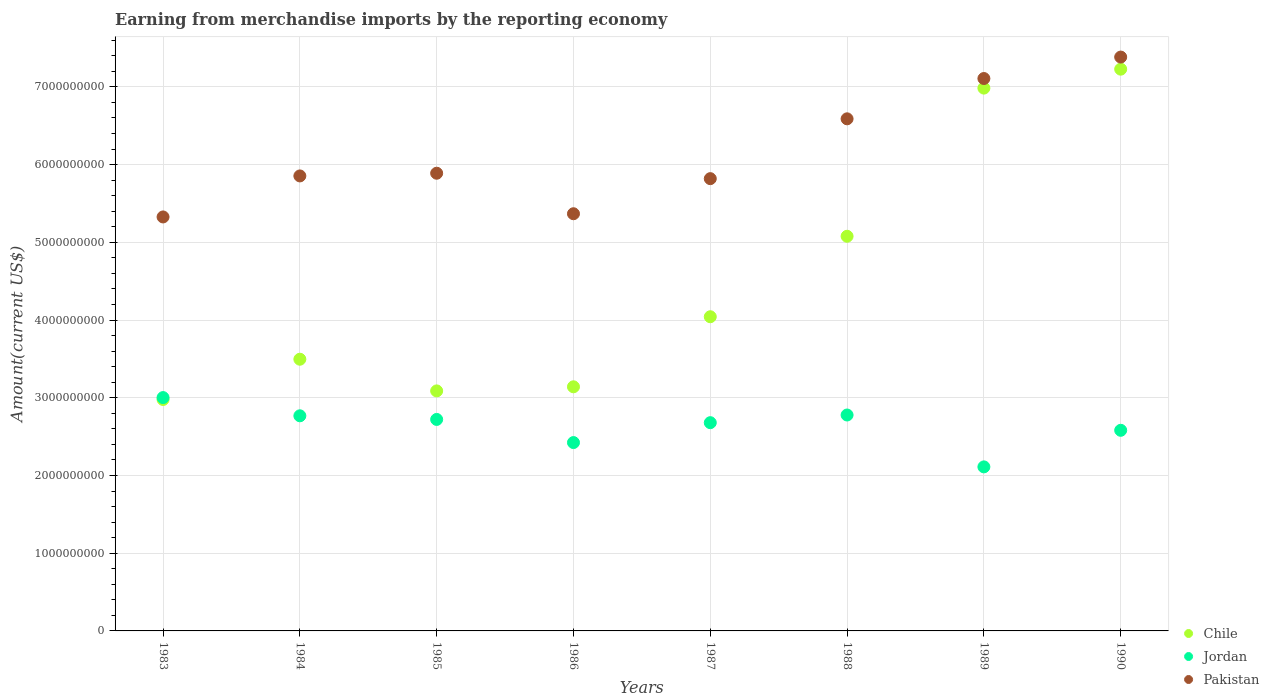What is the amount earned from merchandise imports in Chile in 1985?
Provide a succinct answer. 3.09e+09. Across all years, what is the maximum amount earned from merchandise imports in Pakistan?
Give a very brief answer. 7.38e+09. Across all years, what is the minimum amount earned from merchandise imports in Pakistan?
Your response must be concise. 5.33e+09. In which year was the amount earned from merchandise imports in Pakistan maximum?
Your answer should be very brief. 1990. In which year was the amount earned from merchandise imports in Chile minimum?
Provide a succinct answer. 1983. What is the total amount earned from merchandise imports in Chile in the graph?
Make the answer very short. 3.60e+1. What is the difference between the amount earned from merchandise imports in Chile in 1986 and that in 1988?
Offer a very short reply. -1.94e+09. What is the difference between the amount earned from merchandise imports in Jordan in 1985 and the amount earned from merchandise imports in Pakistan in 1988?
Your response must be concise. -3.87e+09. What is the average amount earned from merchandise imports in Jordan per year?
Your answer should be very brief. 2.63e+09. In the year 1987, what is the difference between the amount earned from merchandise imports in Pakistan and amount earned from merchandise imports in Jordan?
Give a very brief answer. 3.14e+09. In how many years, is the amount earned from merchandise imports in Pakistan greater than 3400000000 US$?
Provide a short and direct response. 8. What is the ratio of the amount earned from merchandise imports in Jordan in 1983 to that in 1985?
Keep it short and to the point. 1.1. Is the amount earned from merchandise imports in Pakistan in 1985 less than that in 1988?
Provide a succinct answer. Yes. Is the difference between the amount earned from merchandise imports in Pakistan in 1983 and 1986 greater than the difference between the amount earned from merchandise imports in Jordan in 1983 and 1986?
Offer a terse response. No. What is the difference between the highest and the second highest amount earned from merchandise imports in Chile?
Ensure brevity in your answer.  2.44e+08. What is the difference between the highest and the lowest amount earned from merchandise imports in Chile?
Your answer should be very brief. 4.25e+09. In how many years, is the amount earned from merchandise imports in Pakistan greater than the average amount earned from merchandise imports in Pakistan taken over all years?
Your answer should be very brief. 3. Is the sum of the amount earned from merchandise imports in Jordan in 1983 and 1984 greater than the maximum amount earned from merchandise imports in Chile across all years?
Ensure brevity in your answer.  No. Does the amount earned from merchandise imports in Jordan monotonically increase over the years?
Provide a short and direct response. No. Is the amount earned from merchandise imports in Chile strictly less than the amount earned from merchandise imports in Jordan over the years?
Give a very brief answer. No. How many dotlines are there?
Keep it short and to the point. 3. Are the values on the major ticks of Y-axis written in scientific E-notation?
Provide a succinct answer. No. How are the legend labels stacked?
Your answer should be compact. Vertical. What is the title of the graph?
Your response must be concise. Earning from merchandise imports by the reporting economy. Does "Central African Republic" appear as one of the legend labels in the graph?
Ensure brevity in your answer.  No. What is the label or title of the X-axis?
Keep it short and to the point. Years. What is the label or title of the Y-axis?
Your response must be concise. Amount(current US$). What is the Amount(current US$) of Chile in 1983?
Make the answer very short. 2.98e+09. What is the Amount(current US$) in Jordan in 1983?
Offer a very short reply. 3.00e+09. What is the Amount(current US$) of Pakistan in 1983?
Offer a very short reply. 5.33e+09. What is the Amount(current US$) of Chile in 1984?
Offer a very short reply. 3.50e+09. What is the Amount(current US$) of Jordan in 1984?
Offer a terse response. 2.77e+09. What is the Amount(current US$) of Pakistan in 1984?
Ensure brevity in your answer.  5.85e+09. What is the Amount(current US$) of Chile in 1985?
Give a very brief answer. 3.09e+09. What is the Amount(current US$) in Jordan in 1985?
Offer a very short reply. 2.72e+09. What is the Amount(current US$) in Pakistan in 1985?
Ensure brevity in your answer.  5.89e+09. What is the Amount(current US$) of Chile in 1986?
Keep it short and to the point. 3.14e+09. What is the Amount(current US$) in Jordan in 1986?
Your answer should be compact. 2.42e+09. What is the Amount(current US$) of Pakistan in 1986?
Your answer should be compact. 5.37e+09. What is the Amount(current US$) of Chile in 1987?
Your answer should be very brief. 4.04e+09. What is the Amount(current US$) of Jordan in 1987?
Your answer should be very brief. 2.68e+09. What is the Amount(current US$) of Pakistan in 1987?
Give a very brief answer. 5.82e+09. What is the Amount(current US$) in Chile in 1988?
Give a very brief answer. 5.08e+09. What is the Amount(current US$) of Jordan in 1988?
Give a very brief answer. 2.78e+09. What is the Amount(current US$) of Pakistan in 1988?
Offer a terse response. 6.59e+09. What is the Amount(current US$) in Chile in 1989?
Give a very brief answer. 6.98e+09. What is the Amount(current US$) in Jordan in 1989?
Offer a terse response. 2.11e+09. What is the Amount(current US$) of Pakistan in 1989?
Provide a short and direct response. 7.11e+09. What is the Amount(current US$) of Chile in 1990?
Make the answer very short. 7.23e+09. What is the Amount(current US$) of Jordan in 1990?
Your answer should be compact. 2.58e+09. What is the Amount(current US$) of Pakistan in 1990?
Offer a very short reply. 7.38e+09. Across all years, what is the maximum Amount(current US$) of Chile?
Your response must be concise. 7.23e+09. Across all years, what is the maximum Amount(current US$) in Jordan?
Offer a terse response. 3.00e+09. Across all years, what is the maximum Amount(current US$) in Pakistan?
Give a very brief answer. 7.38e+09. Across all years, what is the minimum Amount(current US$) in Chile?
Make the answer very short. 2.98e+09. Across all years, what is the minimum Amount(current US$) in Jordan?
Your response must be concise. 2.11e+09. Across all years, what is the minimum Amount(current US$) of Pakistan?
Give a very brief answer. 5.33e+09. What is the total Amount(current US$) of Chile in the graph?
Keep it short and to the point. 3.60e+1. What is the total Amount(current US$) of Jordan in the graph?
Offer a terse response. 2.11e+1. What is the total Amount(current US$) of Pakistan in the graph?
Provide a short and direct response. 4.93e+1. What is the difference between the Amount(current US$) of Chile in 1983 and that in 1984?
Keep it short and to the point. -5.18e+08. What is the difference between the Amount(current US$) of Jordan in 1983 and that in 1984?
Keep it short and to the point. 2.34e+08. What is the difference between the Amount(current US$) in Pakistan in 1983 and that in 1984?
Offer a terse response. -5.28e+08. What is the difference between the Amount(current US$) in Chile in 1983 and that in 1985?
Give a very brief answer. -1.10e+08. What is the difference between the Amount(current US$) of Jordan in 1983 and that in 1985?
Your response must be concise. 2.81e+08. What is the difference between the Amount(current US$) of Pakistan in 1983 and that in 1985?
Your response must be concise. -5.62e+08. What is the difference between the Amount(current US$) in Chile in 1983 and that in 1986?
Your answer should be compact. -1.63e+08. What is the difference between the Amount(current US$) of Jordan in 1983 and that in 1986?
Your answer should be very brief. 5.79e+08. What is the difference between the Amount(current US$) of Pakistan in 1983 and that in 1986?
Your answer should be compact. -4.12e+07. What is the difference between the Amount(current US$) of Chile in 1983 and that in 1987?
Offer a terse response. -1.06e+09. What is the difference between the Amount(current US$) in Jordan in 1983 and that in 1987?
Offer a terse response. 3.23e+08. What is the difference between the Amount(current US$) of Pakistan in 1983 and that in 1987?
Your response must be concise. -4.93e+08. What is the difference between the Amount(current US$) of Chile in 1983 and that in 1988?
Provide a short and direct response. -2.10e+09. What is the difference between the Amount(current US$) in Jordan in 1983 and that in 1988?
Make the answer very short. 2.24e+08. What is the difference between the Amount(current US$) of Pakistan in 1983 and that in 1988?
Provide a succinct answer. -1.26e+09. What is the difference between the Amount(current US$) of Chile in 1983 and that in 1989?
Offer a very short reply. -4.01e+09. What is the difference between the Amount(current US$) of Jordan in 1983 and that in 1989?
Provide a short and direct response. 8.91e+08. What is the difference between the Amount(current US$) of Pakistan in 1983 and that in 1989?
Provide a short and direct response. -1.78e+09. What is the difference between the Amount(current US$) in Chile in 1983 and that in 1990?
Provide a short and direct response. -4.25e+09. What is the difference between the Amount(current US$) in Jordan in 1983 and that in 1990?
Provide a short and direct response. 4.21e+08. What is the difference between the Amount(current US$) of Pakistan in 1983 and that in 1990?
Keep it short and to the point. -2.06e+09. What is the difference between the Amount(current US$) of Chile in 1984 and that in 1985?
Give a very brief answer. 4.08e+08. What is the difference between the Amount(current US$) of Jordan in 1984 and that in 1985?
Provide a succinct answer. 4.66e+07. What is the difference between the Amount(current US$) of Pakistan in 1984 and that in 1985?
Ensure brevity in your answer.  -3.47e+07. What is the difference between the Amount(current US$) of Chile in 1984 and that in 1986?
Offer a terse response. 3.55e+08. What is the difference between the Amount(current US$) in Jordan in 1984 and that in 1986?
Provide a succinct answer. 3.44e+08. What is the difference between the Amount(current US$) of Pakistan in 1984 and that in 1986?
Offer a terse response. 4.87e+08. What is the difference between the Amount(current US$) of Chile in 1984 and that in 1987?
Offer a terse response. -5.47e+08. What is the difference between the Amount(current US$) of Jordan in 1984 and that in 1987?
Your answer should be very brief. 8.84e+07. What is the difference between the Amount(current US$) in Pakistan in 1984 and that in 1987?
Your answer should be very brief. 3.51e+07. What is the difference between the Amount(current US$) of Chile in 1984 and that in 1988?
Your response must be concise. -1.58e+09. What is the difference between the Amount(current US$) in Jordan in 1984 and that in 1988?
Provide a short and direct response. -1.03e+07. What is the difference between the Amount(current US$) in Pakistan in 1984 and that in 1988?
Provide a succinct answer. -7.35e+08. What is the difference between the Amount(current US$) in Chile in 1984 and that in 1989?
Your answer should be compact. -3.49e+09. What is the difference between the Amount(current US$) in Jordan in 1984 and that in 1989?
Give a very brief answer. 6.57e+08. What is the difference between the Amount(current US$) in Pakistan in 1984 and that in 1989?
Your answer should be compact. -1.25e+09. What is the difference between the Amount(current US$) of Chile in 1984 and that in 1990?
Your answer should be very brief. -3.73e+09. What is the difference between the Amount(current US$) of Jordan in 1984 and that in 1990?
Keep it short and to the point. 1.87e+08. What is the difference between the Amount(current US$) in Pakistan in 1984 and that in 1990?
Provide a succinct answer. -1.53e+09. What is the difference between the Amount(current US$) of Chile in 1985 and that in 1986?
Ensure brevity in your answer.  -5.28e+07. What is the difference between the Amount(current US$) in Jordan in 1985 and that in 1986?
Offer a terse response. 2.98e+08. What is the difference between the Amount(current US$) of Pakistan in 1985 and that in 1986?
Make the answer very short. 5.21e+08. What is the difference between the Amount(current US$) of Chile in 1985 and that in 1987?
Your answer should be compact. -9.54e+08. What is the difference between the Amount(current US$) of Jordan in 1985 and that in 1987?
Make the answer very short. 4.18e+07. What is the difference between the Amount(current US$) of Pakistan in 1985 and that in 1987?
Offer a terse response. 6.98e+07. What is the difference between the Amount(current US$) of Chile in 1985 and that in 1988?
Offer a terse response. -1.99e+09. What is the difference between the Amount(current US$) of Jordan in 1985 and that in 1988?
Ensure brevity in your answer.  -5.70e+07. What is the difference between the Amount(current US$) in Pakistan in 1985 and that in 1988?
Your answer should be very brief. -7.00e+08. What is the difference between the Amount(current US$) in Chile in 1985 and that in 1989?
Ensure brevity in your answer.  -3.90e+09. What is the difference between the Amount(current US$) in Jordan in 1985 and that in 1989?
Your answer should be very brief. 6.10e+08. What is the difference between the Amount(current US$) in Pakistan in 1985 and that in 1989?
Provide a short and direct response. -1.22e+09. What is the difference between the Amount(current US$) of Chile in 1985 and that in 1990?
Make the answer very short. -4.14e+09. What is the difference between the Amount(current US$) of Jordan in 1985 and that in 1990?
Your response must be concise. 1.40e+08. What is the difference between the Amount(current US$) in Pakistan in 1985 and that in 1990?
Offer a very short reply. -1.49e+09. What is the difference between the Amount(current US$) of Chile in 1986 and that in 1987?
Your answer should be very brief. -9.01e+08. What is the difference between the Amount(current US$) of Jordan in 1986 and that in 1987?
Your answer should be compact. -2.56e+08. What is the difference between the Amount(current US$) of Pakistan in 1986 and that in 1987?
Provide a short and direct response. -4.52e+08. What is the difference between the Amount(current US$) in Chile in 1986 and that in 1988?
Give a very brief answer. -1.94e+09. What is the difference between the Amount(current US$) in Jordan in 1986 and that in 1988?
Your response must be concise. -3.55e+08. What is the difference between the Amount(current US$) of Pakistan in 1986 and that in 1988?
Your answer should be compact. -1.22e+09. What is the difference between the Amount(current US$) of Chile in 1986 and that in 1989?
Keep it short and to the point. -3.84e+09. What is the difference between the Amount(current US$) of Jordan in 1986 and that in 1989?
Keep it short and to the point. 3.13e+08. What is the difference between the Amount(current US$) of Pakistan in 1986 and that in 1989?
Your answer should be very brief. -1.74e+09. What is the difference between the Amount(current US$) of Chile in 1986 and that in 1990?
Offer a very short reply. -4.09e+09. What is the difference between the Amount(current US$) of Jordan in 1986 and that in 1990?
Offer a terse response. -1.58e+08. What is the difference between the Amount(current US$) in Pakistan in 1986 and that in 1990?
Offer a very short reply. -2.02e+09. What is the difference between the Amount(current US$) of Chile in 1987 and that in 1988?
Provide a short and direct response. -1.04e+09. What is the difference between the Amount(current US$) in Jordan in 1987 and that in 1988?
Give a very brief answer. -9.88e+07. What is the difference between the Amount(current US$) of Pakistan in 1987 and that in 1988?
Your answer should be compact. -7.70e+08. What is the difference between the Amount(current US$) in Chile in 1987 and that in 1989?
Provide a short and direct response. -2.94e+09. What is the difference between the Amount(current US$) of Jordan in 1987 and that in 1989?
Keep it short and to the point. 5.69e+08. What is the difference between the Amount(current US$) of Pakistan in 1987 and that in 1989?
Your response must be concise. -1.29e+09. What is the difference between the Amount(current US$) of Chile in 1987 and that in 1990?
Your answer should be very brief. -3.19e+09. What is the difference between the Amount(current US$) in Jordan in 1987 and that in 1990?
Offer a terse response. 9.81e+07. What is the difference between the Amount(current US$) of Pakistan in 1987 and that in 1990?
Provide a short and direct response. -1.56e+09. What is the difference between the Amount(current US$) of Chile in 1988 and that in 1989?
Make the answer very short. -1.91e+09. What is the difference between the Amount(current US$) in Jordan in 1988 and that in 1989?
Offer a very short reply. 6.67e+08. What is the difference between the Amount(current US$) of Pakistan in 1988 and that in 1989?
Give a very brief answer. -5.19e+08. What is the difference between the Amount(current US$) of Chile in 1988 and that in 1990?
Give a very brief answer. -2.15e+09. What is the difference between the Amount(current US$) of Jordan in 1988 and that in 1990?
Your answer should be very brief. 1.97e+08. What is the difference between the Amount(current US$) in Pakistan in 1988 and that in 1990?
Your answer should be compact. -7.95e+08. What is the difference between the Amount(current US$) of Chile in 1989 and that in 1990?
Your response must be concise. -2.44e+08. What is the difference between the Amount(current US$) of Jordan in 1989 and that in 1990?
Keep it short and to the point. -4.71e+08. What is the difference between the Amount(current US$) in Pakistan in 1989 and that in 1990?
Your answer should be very brief. -2.76e+08. What is the difference between the Amount(current US$) in Chile in 1983 and the Amount(current US$) in Jordan in 1984?
Your answer should be compact. 2.10e+08. What is the difference between the Amount(current US$) in Chile in 1983 and the Amount(current US$) in Pakistan in 1984?
Your answer should be compact. -2.88e+09. What is the difference between the Amount(current US$) of Jordan in 1983 and the Amount(current US$) of Pakistan in 1984?
Make the answer very short. -2.85e+09. What is the difference between the Amount(current US$) in Chile in 1983 and the Amount(current US$) in Jordan in 1985?
Provide a succinct answer. 2.57e+08. What is the difference between the Amount(current US$) in Chile in 1983 and the Amount(current US$) in Pakistan in 1985?
Your answer should be compact. -2.91e+09. What is the difference between the Amount(current US$) in Jordan in 1983 and the Amount(current US$) in Pakistan in 1985?
Provide a short and direct response. -2.89e+09. What is the difference between the Amount(current US$) in Chile in 1983 and the Amount(current US$) in Jordan in 1986?
Keep it short and to the point. 5.54e+08. What is the difference between the Amount(current US$) in Chile in 1983 and the Amount(current US$) in Pakistan in 1986?
Your answer should be compact. -2.39e+09. What is the difference between the Amount(current US$) of Jordan in 1983 and the Amount(current US$) of Pakistan in 1986?
Provide a succinct answer. -2.37e+09. What is the difference between the Amount(current US$) of Chile in 1983 and the Amount(current US$) of Jordan in 1987?
Provide a succinct answer. 2.98e+08. What is the difference between the Amount(current US$) of Chile in 1983 and the Amount(current US$) of Pakistan in 1987?
Provide a short and direct response. -2.84e+09. What is the difference between the Amount(current US$) of Jordan in 1983 and the Amount(current US$) of Pakistan in 1987?
Offer a very short reply. -2.82e+09. What is the difference between the Amount(current US$) of Chile in 1983 and the Amount(current US$) of Jordan in 1988?
Make the answer very short. 2.00e+08. What is the difference between the Amount(current US$) in Chile in 1983 and the Amount(current US$) in Pakistan in 1988?
Your answer should be compact. -3.61e+09. What is the difference between the Amount(current US$) in Jordan in 1983 and the Amount(current US$) in Pakistan in 1988?
Your answer should be very brief. -3.59e+09. What is the difference between the Amount(current US$) of Chile in 1983 and the Amount(current US$) of Jordan in 1989?
Your response must be concise. 8.67e+08. What is the difference between the Amount(current US$) in Chile in 1983 and the Amount(current US$) in Pakistan in 1989?
Ensure brevity in your answer.  -4.13e+09. What is the difference between the Amount(current US$) of Jordan in 1983 and the Amount(current US$) of Pakistan in 1989?
Provide a short and direct response. -4.11e+09. What is the difference between the Amount(current US$) in Chile in 1983 and the Amount(current US$) in Jordan in 1990?
Give a very brief answer. 3.97e+08. What is the difference between the Amount(current US$) in Chile in 1983 and the Amount(current US$) in Pakistan in 1990?
Provide a short and direct response. -4.41e+09. What is the difference between the Amount(current US$) of Jordan in 1983 and the Amount(current US$) of Pakistan in 1990?
Your response must be concise. -4.38e+09. What is the difference between the Amount(current US$) of Chile in 1984 and the Amount(current US$) of Jordan in 1985?
Make the answer very short. 7.75e+08. What is the difference between the Amount(current US$) of Chile in 1984 and the Amount(current US$) of Pakistan in 1985?
Provide a succinct answer. -2.39e+09. What is the difference between the Amount(current US$) in Jordan in 1984 and the Amount(current US$) in Pakistan in 1985?
Ensure brevity in your answer.  -3.12e+09. What is the difference between the Amount(current US$) of Chile in 1984 and the Amount(current US$) of Jordan in 1986?
Provide a short and direct response. 1.07e+09. What is the difference between the Amount(current US$) in Chile in 1984 and the Amount(current US$) in Pakistan in 1986?
Provide a short and direct response. -1.87e+09. What is the difference between the Amount(current US$) in Jordan in 1984 and the Amount(current US$) in Pakistan in 1986?
Your response must be concise. -2.60e+09. What is the difference between the Amount(current US$) in Chile in 1984 and the Amount(current US$) in Jordan in 1987?
Give a very brief answer. 8.16e+08. What is the difference between the Amount(current US$) of Chile in 1984 and the Amount(current US$) of Pakistan in 1987?
Your answer should be very brief. -2.32e+09. What is the difference between the Amount(current US$) in Jordan in 1984 and the Amount(current US$) in Pakistan in 1987?
Keep it short and to the point. -3.05e+09. What is the difference between the Amount(current US$) of Chile in 1984 and the Amount(current US$) of Jordan in 1988?
Offer a very short reply. 7.18e+08. What is the difference between the Amount(current US$) in Chile in 1984 and the Amount(current US$) in Pakistan in 1988?
Give a very brief answer. -3.09e+09. What is the difference between the Amount(current US$) of Jordan in 1984 and the Amount(current US$) of Pakistan in 1988?
Provide a short and direct response. -3.82e+09. What is the difference between the Amount(current US$) in Chile in 1984 and the Amount(current US$) in Jordan in 1989?
Ensure brevity in your answer.  1.38e+09. What is the difference between the Amount(current US$) of Chile in 1984 and the Amount(current US$) of Pakistan in 1989?
Provide a short and direct response. -3.61e+09. What is the difference between the Amount(current US$) of Jordan in 1984 and the Amount(current US$) of Pakistan in 1989?
Keep it short and to the point. -4.34e+09. What is the difference between the Amount(current US$) in Chile in 1984 and the Amount(current US$) in Jordan in 1990?
Your answer should be compact. 9.14e+08. What is the difference between the Amount(current US$) in Chile in 1984 and the Amount(current US$) in Pakistan in 1990?
Offer a terse response. -3.89e+09. What is the difference between the Amount(current US$) of Jordan in 1984 and the Amount(current US$) of Pakistan in 1990?
Your answer should be very brief. -4.62e+09. What is the difference between the Amount(current US$) of Chile in 1985 and the Amount(current US$) of Jordan in 1986?
Make the answer very short. 6.65e+08. What is the difference between the Amount(current US$) in Chile in 1985 and the Amount(current US$) in Pakistan in 1986?
Make the answer very short. -2.28e+09. What is the difference between the Amount(current US$) in Jordan in 1985 and the Amount(current US$) in Pakistan in 1986?
Provide a succinct answer. -2.65e+09. What is the difference between the Amount(current US$) in Chile in 1985 and the Amount(current US$) in Jordan in 1987?
Keep it short and to the point. 4.09e+08. What is the difference between the Amount(current US$) of Chile in 1985 and the Amount(current US$) of Pakistan in 1987?
Your response must be concise. -2.73e+09. What is the difference between the Amount(current US$) in Jordan in 1985 and the Amount(current US$) in Pakistan in 1987?
Your response must be concise. -3.10e+09. What is the difference between the Amount(current US$) of Chile in 1985 and the Amount(current US$) of Jordan in 1988?
Provide a short and direct response. 3.10e+08. What is the difference between the Amount(current US$) in Chile in 1985 and the Amount(current US$) in Pakistan in 1988?
Give a very brief answer. -3.50e+09. What is the difference between the Amount(current US$) of Jordan in 1985 and the Amount(current US$) of Pakistan in 1988?
Offer a terse response. -3.87e+09. What is the difference between the Amount(current US$) in Chile in 1985 and the Amount(current US$) in Jordan in 1989?
Your answer should be very brief. 9.77e+08. What is the difference between the Amount(current US$) in Chile in 1985 and the Amount(current US$) in Pakistan in 1989?
Provide a short and direct response. -4.02e+09. What is the difference between the Amount(current US$) of Jordan in 1985 and the Amount(current US$) of Pakistan in 1989?
Ensure brevity in your answer.  -4.39e+09. What is the difference between the Amount(current US$) in Chile in 1985 and the Amount(current US$) in Jordan in 1990?
Ensure brevity in your answer.  5.07e+08. What is the difference between the Amount(current US$) of Chile in 1985 and the Amount(current US$) of Pakistan in 1990?
Keep it short and to the point. -4.30e+09. What is the difference between the Amount(current US$) in Jordan in 1985 and the Amount(current US$) in Pakistan in 1990?
Make the answer very short. -4.66e+09. What is the difference between the Amount(current US$) of Chile in 1986 and the Amount(current US$) of Jordan in 1987?
Make the answer very short. 4.62e+08. What is the difference between the Amount(current US$) of Chile in 1986 and the Amount(current US$) of Pakistan in 1987?
Make the answer very short. -2.68e+09. What is the difference between the Amount(current US$) of Jordan in 1986 and the Amount(current US$) of Pakistan in 1987?
Give a very brief answer. -3.40e+09. What is the difference between the Amount(current US$) in Chile in 1986 and the Amount(current US$) in Jordan in 1988?
Offer a terse response. 3.63e+08. What is the difference between the Amount(current US$) of Chile in 1986 and the Amount(current US$) of Pakistan in 1988?
Offer a terse response. -3.45e+09. What is the difference between the Amount(current US$) of Jordan in 1986 and the Amount(current US$) of Pakistan in 1988?
Keep it short and to the point. -4.17e+09. What is the difference between the Amount(current US$) of Chile in 1986 and the Amount(current US$) of Jordan in 1989?
Keep it short and to the point. 1.03e+09. What is the difference between the Amount(current US$) in Chile in 1986 and the Amount(current US$) in Pakistan in 1989?
Keep it short and to the point. -3.97e+09. What is the difference between the Amount(current US$) in Jordan in 1986 and the Amount(current US$) in Pakistan in 1989?
Provide a succinct answer. -4.68e+09. What is the difference between the Amount(current US$) in Chile in 1986 and the Amount(current US$) in Jordan in 1990?
Your answer should be compact. 5.60e+08. What is the difference between the Amount(current US$) in Chile in 1986 and the Amount(current US$) in Pakistan in 1990?
Make the answer very short. -4.24e+09. What is the difference between the Amount(current US$) in Jordan in 1986 and the Amount(current US$) in Pakistan in 1990?
Provide a short and direct response. -4.96e+09. What is the difference between the Amount(current US$) in Chile in 1987 and the Amount(current US$) in Jordan in 1988?
Give a very brief answer. 1.26e+09. What is the difference between the Amount(current US$) of Chile in 1987 and the Amount(current US$) of Pakistan in 1988?
Offer a very short reply. -2.55e+09. What is the difference between the Amount(current US$) of Jordan in 1987 and the Amount(current US$) of Pakistan in 1988?
Offer a very short reply. -3.91e+09. What is the difference between the Amount(current US$) of Chile in 1987 and the Amount(current US$) of Jordan in 1989?
Offer a terse response. 1.93e+09. What is the difference between the Amount(current US$) in Chile in 1987 and the Amount(current US$) in Pakistan in 1989?
Give a very brief answer. -3.06e+09. What is the difference between the Amount(current US$) in Jordan in 1987 and the Amount(current US$) in Pakistan in 1989?
Give a very brief answer. -4.43e+09. What is the difference between the Amount(current US$) of Chile in 1987 and the Amount(current US$) of Jordan in 1990?
Ensure brevity in your answer.  1.46e+09. What is the difference between the Amount(current US$) of Chile in 1987 and the Amount(current US$) of Pakistan in 1990?
Offer a very short reply. -3.34e+09. What is the difference between the Amount(current US$) of Jordan in 1987 and the Amount(current US$) of Pakistan in 1990?
Your response must be concise. -4.70e+09. What is the difference between the Amount(current US$) of Chile in 1988 and the Amount(current US$) of Jordan in 1989?
Provide a succinct answer. 2.97e+09. What is the difference between the Amount(current US$) in Chile in 1988 and the Amount(current US$) in Pakistan in 1989?
Make the answer very short. -2.03e+09. What is the difference between the Amount(current US$) of Jordan in 1988 and the Amount(current US$) of Pakistan in 1989?
Provide a short and direct response. -4.33e+09. What is the difference between the Amount(current US$) in Chile in 1988 and the Amount(current US$) in Jordan in 1990?
Your response must be concise. 2.50e+09. What is the difference between the Amount(current US$) of Chile in 1988 and the Amount(current US$) of Pakistan in 1990?
Keep it short and to the point. -2.31e+09. What is the difference between the Amount(current US$) in Jordan in 1988 and the Amount(current US$) in Pakistan in 1990?
Offer a terse response. -4.61e+09. What is the difference between the Amount(current US$) of Chile in 1989 and the Amount(current US$) of Jordan in 1990?
Your response must be concise. 4.40e+09. What is the difference between the Amount(current US$) in Chile in 1989 and the Amount(current US$) in Pakistan in 1990?
Offer a terse response. -3.99e+08. What is the difference between the Amount(current US$) in Jordan in 1989 and the Amount(current US$) in Pakistan in 1990?
Make the answer very short. -5.27e+09. What is the average Amount(current US$) in Chile per year?
Provide a short and direct response. 4.50e+09. What is the average Amount(current US$) of Jordan per year?
Provide a succinct answer. 2.63e+09. What is the average Amount(current US$) of Pakistan per year?
Keep it short and to the point. 6.17e+09. In the year 1983, what is the difference between the Amount(current US$) of Chile and Amount(current US$) of Jordan?
Your response must be concise. -2.44e+07. In the year 1983, what is the difference between the Amount(current US$) of Chile and Amount(current US$) of Pakistan?
Your answer should be compact. -2.35e+09. In the year 1983, what is the difference between the Amount(current US$) of Jordan and Amount(current US$) of Pakistan?
Provide a short and direct response. -2.32e+09. In the year 1984, what is the difference between the Amount(current US$) of Chile and Amount(current US$) of Jordan?
Offer a terse response. 7.28e+08. In the year 1984, what is the difference between the Amount(current US$) of Chile and Amount(current US$) of Pakistan?
Make the answer very short. -2.36e+09. In the year 1984, what is the difference between the Amount(current US$) in Jordan and Amount(current US$) in Pakistan?
Your answer should be compact. -3.09e+09. In the year 1985, what is the difference between the Amount(current US$) in Chile and Amount(current US$) in Jordan?
Your response must be concise. 3.67e+08. In the year 1985, what is the difference between the Amount(current US$) of Chile and Amount(current US$) of Pakistan?
Provide a succinct answer. -2.80e+09. In the year 1985, what is the difference between the Amount(current US$) in Jordan and Amount(current US$) in Pakistan?
Your response must be concise. -3.17e+09. In the year 1986, what is the difference between the Amount(current US$) in Chile and Amount(current US$) in Jordan?
Give a very brief answer. 7.18e+08. In the year 1986, what is the difference between the Amount(current US$) of Chile and Amount(current US$) of Pakistan?
Provide a short and direct response. -2.23e+09. In the year 1986, what is the difference between the Amount(current US$) of Jordan and Amount(current US$) of Pakistan?
Provide a short and direct response. -2.94e+09. In the year 1987, what is the difference between the Amount(current US$) of Chile and Amount(current US$) of Jordan?
Your answer should be very brief. 1.36e+09. In the year 1987, what is the difference between the Amount(current US$) of Chile and Amount(current US$) of Pakistan?
Your response must be concise. -1.78e+09. In the year 1987, what is the difference between the Amount(current US$) of Jordan and Amount(current US$) of Pakistan?
Provide a succinct answer. -3.14e+09. In the year 1988, what is the difference between the Amount(current US$) of Chile and Amount(current US$) of Jordan?
Keep it short and to the point. 2.30e+09. In the year 1988, what is the difference between the Amount(current US$) in Chile and Amount(current US$) in Pakistan?
Your response must be concise. -1.51e+09. In the year 1988, what is the difference between the Amount(current US$) of Jordan and Amount(current US$) of Pakistan?
Your answer should be compact. -3.81e+09. In the year 1989, what is the difference between the Amount(current US$) in Chile and Amount(current US$) in Jordan?
Your answer should be compact. 4.87e+09. In the year 1989, what is the difference between the Amount(current US$) in Chile and Amount(current US$) in Pakistan?
Give a very brief answer. -1.23e+08. In the year 1989, what is the difference between the Amount(current US$) in Jordan and Amount(current US$) in Pakistan?
Ensure brevity in your answer.  -5.00e+09. In the year 1990, what is the difference between the Amount(current US$) of Chile and Amount(current US$) of Jordan?
Offer a very short reply. 4.65e+09. In the year 1990, what is the difference between the Amount(current US$) of Chile and Amount(current US$) of Pakistan?
Give a very brief answer. -1.56e+08. In the year 1990, what is the difference between the Amount(current US$) of Jordan and Amount(current US$) of Pakistan?
Your answer should be compact. -4.80e+09. What is the ratio of the Amount(current US$) of Chile in 1983 to that in 1984?
Make the answer very short. 0.85. What is the ratio of the Amount(current US$) in Jordan in 1983 to that in 1984?
Give a very brief answer. 1.08. What is the ratio of the Amount(current US$) in Pakistan in 1983 to that in 1984?
Your response must be concise. 0.91. What is the ratio of the Amount(current US$) of Chile in 1983 to that in 1985?
Make the answer very short. 0.96. What is the ratio of the Amount(current US$) in Jordan in 1983 to that in 1985?
Provide a short and direct response. 1.1. What is the ratio of the Amount(current US$) in Pakistan in 1983 to that in 1985?
Provide a succinct answer. 0.9. What is the ratio of the Amount(current US$) in Chile in 1983 to that in 1986?
Make the answer very short. 0.95. What is the ratio of the Amount(current US$) of Jordan in 1983 to that in 1986?
Ensure brevity in your answer.  1.24. What is the ratio of the Amount(current US$) in Chile in 1983 to that in 1987?
Offer a terse response. 0.74. What is the ratio of the Amount(current US$) of Jordan in 1983 to that in 1987?
Offer a terse response. 1.12. What is the ratio of the Amount(current US$) of Pakistan in 1983 to that in 1987?
Provide a succinct answer. 0.92. What is the ratio of the Amount(current US$) of Chile in 1983 to that in 1988?
Your answer should be very brief. 0.59. What is the ratio of the Amount(current US$) in Jordan in 1983 to that in 1988?
Offer a terse response. 1.08. What is the ratio of the Amount(current US$) of Pakistan in 1983 to that in 1988?
Make the answer very short. 0.81. What is the ratio of the Amount(current US$) of Chile in 1983 to that in 1989?
Your answer should be compact. 0.43. What is the ratio of the Amount(current US$) of Jordan in 1983 to that in 1989?
Provide a short and direct response. 1.42. What is the ratio of the Amount(current US$) in Pakistan in 1983 to that in 1989?
Ensure brevity in your answer.  0.75. What is the ratio of the Amount(current US$) of Chile in 1983 to that in 1990?
Your response must be concise. 0.41. What is the ratio of the Amount(current US$) of Jordan in 1983 to that in 1990?
Your answer should be compact. 1.16. What is the ratio of the Amount(current US$) in Pakistan in 1983 to that in 1990?
Offer a terse response. 0.72. What is the ratio of the Amount(current US$) in Chile in 1984 to that in 1985?
Offer a very short reply. 1.13. What is the ratio of the Amount(current US$) of Jordan in 1984 to that in 1985?
Your answer should be compact. 1.02. What is the ratio of the Amount(current US$) in Chile in 1984 to that in 1986?
Your answer should be very brief. 1.11. What is the ratio of the Amount(current US$) of Jordan in 1984 to that in 1986?
Your response must be concise. 1.14. What is the ratio of the Amount(current US$) in Pakistan in 1984 to that in 1986?
Keep it short and to the point. 1.09. What is the ratio of the Amount(current US$) of Chile in 1984 to that in 1987?
Offer a very short reply. 0.86. What is the ratio of the Amount(current US$) of Jordan in 1984 to that in 1987?
Make the answer very short. 1.03. What is the ratio of the Amount(current US$) of Chile in 1984 to that in 1988?
Make the answer very short. 0.69. What is the ratio of the Amount(current US$) of Jordan in 1984 to that in 1988?
Offer a very short reply. 1. What is the ratio of the Amount(current US$) of Pakistan in 1984 to that in 1988?
Give a very brief answer. 0.89. What is the ratio of the Amount(current US$) in Chile in 1984 to that in 1989?
Make the answer very short. 0.5. What is the ratio of the Amount(current US$) of Jordan in 1984 to that in 1989?
Offer a very short reply. 1.31. What is the ratio of the Amount(current US$) of Pakistan in 1984 to that in 1989?
Make the answer very short. 0.82. What is the ratio of the Amount(current US$) in Chile in 1984 to that in 1990?
Ensure brevity in your answer.  0.48. What is the ratio of the Amount(current US$) in Jordan in 1984 to that in 1990?
Keep it short and to the point. 1.07. What is the ratio of the Amount(current US$) of Pakistan in 1984 to that in 1990?
Your answer should be compact. 0.79. What is the ratio of the Amount(current US$) in Chile in 1985 to that in 1986?
Give a very brief answer. 0.98. What is the ratio of the Amount(current US$) in Jordan in 1985 to that in 1986?
Your answer should be very brief. 1.12. What is the ratio of the Amount(current US$) of Pakistan in 1985 to that in 1986?
Your answer should be very brief. 1.1. What is the ratio of the Amount(current US$) of Chile in 1985 to that in 1987?
Give a very brief answer. 0.76. What is the ratio of the Amount(current US$) of Jordan in 1985 to that in 1987?
Offer a terse response. 1.02. What is the ratio of the Amount(current US$) of Chile in 1985 to that in 1988?
Your answer should be very brief. 0.61. What is the ratio of the Amount(current US$) in Jordan in 1985 to that in 1988?
Provide a short and direct response. 0.98. What is the ratio of the Amount(current US$) in Pakistan in 1985 to that in 1988?
Give a very brief answer. 0.89. What is the ratio of the Amount(current US$) of Chile in 1985 to that in 1989?
Give a very brief answer. 0.44. What is the ratio of the Amount(current US$) of Jordan in 1985 to that in 1989?
Provide a succinct answer. 1.29. What is the ratio of the Amount(current US$) of Pakistan in 1985 to that in 1989?
Provide a short and direct response. 0.83. What is the ratio of the Amount(current US$) of Chile in 1985 to that in 1990?
Keep it short and to the point. 0.43. What is the ratio of the Amount(current US$) in Jordan in 1985 to that in 1990?
Your answer should be compact. 1.05. What is the ratio of the Amount(current US$) in Pakistan in 1985 to that in 1990?
Your response must be concise. 0.8. What is the ratio of the Amount(current US$) of Chile in 1986 to that in 1987?
Provide a succinct answer. 0.78. What is the ratio of the Amount(current US$) of Jordan in 1986 to that in 1987?
Your response must be concise. 0.9. What is the ratio of the Amount(current US$) of Pakistan in 1986 to that in 1987?
Your answer should be very brief. 0.92. What is the ratio of the Amount(current US$) of Chile in 1986 to that in 1988?
Your response must be concise. 0.62. What is the ratio of the Amount(current US$) of Jordan in 1986 to that in 1988?
Offer a terse response. 0.87. What is the ratio of the Amount(current US$) of Pakistan in 1986 to that in 1988?
Your answer should be compact. 0.81. What is the ratio of the Amount(current US$) of Chile in 1986 to that in 1989?
Offer a terse response. 0.45. What is the ratio of the Amount(current US$) of Jordan in 1986 to that in 1989?
Keep it short and to the point. 1.15. What is the ratio of the Amount(current US$) of Pakistan in 1986 to that in 1989?
Your answer should be very brief. 0.76. What is the ratio of the Amount(current US$) of Chile in 1986 to that in 1990?
Your response must be concise. 0.43. What is the ratio of the Amount(current US$) of Jordan in 1986 to that in 1990?
Give a very brief answer. 0.94. What is the ratio of the Amount(current US$) of Pakistan in 1986 to that in 1990?
Provide a short and direct response. 0.73. What is the ratio of the Amount(current US$) in Chile in 1987 to that in 1988?
Your answer should be very brief. 0.8. What is the ratio of the Amount(current US$) of Jordan in 1987 to that in 1988?
Offer a terse response. 0.96. What is the ratio of the Amount(current US$) in Pakistan in 1987 to that in 1988?
Offer a terse response. 0.88. What is the ratio of the Amount(current US$) in Chile in 1987 to that in 1989?
Make the answer very short. 0.58. What is the ratio of the Amount(current US$) of Jordan in 1987 to that in 1989?
Offer a very short reply. 1.27. What is the ratio of the Amount(current US$) of Pakistan in 1987 to that in 1989?
Keep it short and to the point. 0.82. What is the ratio of the Amount(current US$) of Chile in 1987 to that in 1990?
Offer a very short reply. 0.56. What is the ratio of the Amount(current US$) in Jordan in 1987 to that in 1990?
Give a very brief answer. 1.04. What is the ratio of the Amount(current US$) of Pakistan in 1987 to that in 1990?
Your answer should be compact. 0.79. What is the ratio of the Amount(current US$) in Chile in 1988 to that in 1989?
Provide a short and direct response. 0.73. What is the ratio of the Amount(current US$) of Jordan in 1988 to that in 1989?
Keep it short and to the point. 1.32. What is the ratio of the Amount(current US$) of Pakistan in 1988 to that in 1989?
Your answer should be compact. 0.93. What is the ratio of the Amount(current US$) of Chile in 1988 to that in 1990?
Provide a succinct answer. 0.7. What is the ratio of the Amount(current US$) of Jordan in 1988 to that in 1990?
Provide a succinct answer. 1.08. What is the ratio of the Amount(current US$) of Pakistan in 1988 to that in 1990?
Ensure brevity in your answer.  0.89. What is the ratio of the Amount(current US$) of Chile in 1989 to that in 1990?
Provide a short and direct response. 0.97. What is the ratio of the Amount(current US$) in Jordan in 1989 to that in 1990?
Your answer should be compact. 0.82. What is the ratio of the Amount(current US$) of Pakistan in 1989 to that in 1990?
Offer a very short reply. 0.96. What is the difference between the highest and the second highest Amount(current US$) in Chile?
Make the answer very short. 2.44e+08. What is the difference between the highest and the second highest Amount(current US$) of Jordan?
Provide a short and direct response. 2.24e+08. What is the difference between the highest and the second highest Amount(current US$) of Pakistan?
Provide a short and direct response. 2.76e+08. What is the difference between the highest and the lowest Amount(current US$) in Chile?
Ensure brevity in your answer.  4.25e+09. What is the difference between the highest and the lowest Amount(current US$) of Jordan?
Offer a very short reply. 8.91e+08. What is the difference between the highest and the lowest Amount(current US$) in Pakistan?
Keep it short and to the point. 2.06e+09. 